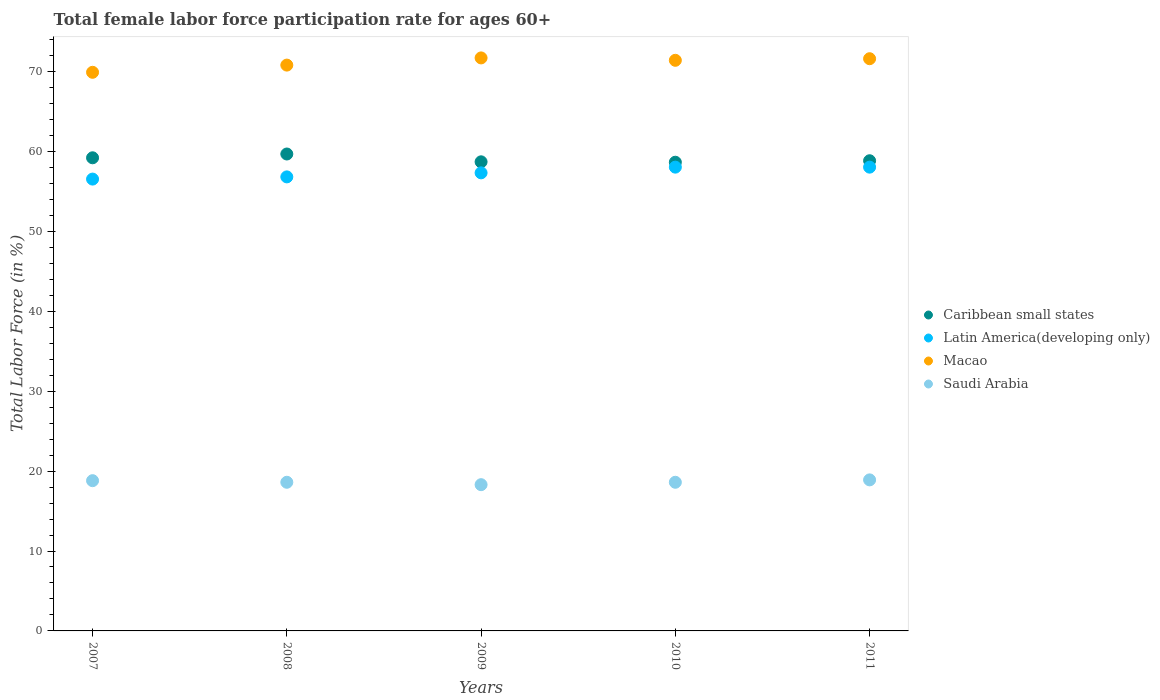How many different coloured dotlines are there?
Ensure brevity in your answer.  4. What is the female labor force participation rate in Saudi Arabia in 2007?
Provide a short and direct response. 18.8. Across all years, what is the maximum female labor force participation rate in Saudi Arabia?
Offer a terse response. 18.9. Across all years, what is the minimum female labor force participation rate in Saudi Arabia?
Your answer should be very brief. 18.3. In which year was the female labor force participation rate in Latin America(developing only) maximum?
Ensure brevity in your answer.  2010. In which year was the female labor force participation rate in Macao minimum?
Make the answer very short. 2007. What is the total female labor force participation rate in Latin America(developing only) in the graph?
Keep it short and to the point. 286.73. What is the difference between the female labor force participation rate in Saudi Arabia in 2008 and that in 2009?
Provide a short and direct response. 0.3. What is the difference between the female labor force participation rate in Saudi Arabia in 2011 and the female labor force participation rate in Macao in 2008?
Provide a succinct answer. -51.9. What is the average female labor force participation rate in Saudi Arabia per year?
Your answer should be very brief. 18.64. In the year 2008, what is the difference between the female labor force participation rate in Caribbean small states and female labor force participation rate in Saudi Arabia?
Your response must be concise. 41.08. In how many years, is the female labor force participation rate in Latin America(developing only) greater than 50 %?
Make the answer very short. 5. What is the ratio of the female labor force participation rate in Caribbean small states in 2009 to that in 2010?
Provide a short and direct response. 1. What is the difference between the highest and the second highest female labor force participation rate in Saudi Arabia?
Make the answer very short. 0.1. What is the difference between the highest and the lowest female labor force participation rate in Caribbean small states?
Keep it short and to the point. 1.03. In how many years, is the female labor force participation rate in Caribbean small states greater than the average female labor force participation rate in Caribbean small states taken over all years?
Offer a terse response. 2. Is the sum of the female labor force participation rate in Macao in 2008 and 2010 greater than the maximum female labor force participation rate in Latin America(developing only) across all years?
Your answer should be compact. Yes. Is it the case that in every year, the sum of the female labor force participation rate in Macao and female labor force participation rate in Latin America(developing only)  is greater than the sum of female labor force participation rate in Caribbean small states and female labor force participation rate in Saudi Arabia?
Provide a short and direct response. Yes. Does the female labor force participation rate in Latin America(developing only) monotonically increase over the years?
Provide a short and direct response. No. Is the female labor force participation rate in Caribbean small states strictly greater than the female labor force participation rate in Saudi Arabia over the years?
Ensure brevity in your answer.  Yes. How many years are there in the graph?
Your response must be concise. 5. Does the graph contain any zero values?
Offer a very short reply. No. Where does the legend appear in the graph?
Offer a terse response. Center right. How many legend labels are there?
Your response must be concise. 4. What is the title of the graph?
Your response must be concise. Total female labor force participation rate for ages 60+. Does "Lesotho" appear as one of the legend labels in the graph?
Your answer should be very brief. No. What is the label or title of the Y-axis?
Offer a very short reply. Total Labor Force (in %). What is the Total Labor Force (in %) in Caribbean small states in 2007?
Provide a short and direct response. 59.2. What is the Total Labor Force (in %) of Latin America(developing only) in 2007?
Make the answer very short. 56.54. What is the Total Labor Force (in %) in Macao in 2007?
Offer a very short reply. 69.9. What is the Total Labor Force (in %) in Saudi Arabia in 2007?
Keep it short and to the point. 18.8. What is the Total Labor Force (in %) in Caribbean small states in 2008?
Keep it short and to the point. 59.68. What is the Total Labor Force (in %) in Latin America(developing only) in 2008?
Offer a terse response. 56.81. What is the Total Labor Force (in %) of Macao in 2008?
Offer a very short reply. 70.8. What is the Total Labor Force (in %) of Saudi Arabia in 2008?
Provide a succinct answer. 18.6. What is the Total Labor Force (in %) in Caribbean small states in 2009?
Your answer should be compact. 58.7. What is the Total Labor Force (in %) in Latin America(developing only) in 2009?
Ensure brevity in your answer.  57.32. What is the Total Labor Force (in %) of Macao in 2009?
Give a very brief answer. 71.7. What is the Total Labor Force (in %) in Saudi Arabia in 2009?
Your response must be concise. 18.3. What is the Total Labor Force (in %) of Caribbean small states in 2010?
Provide a succinct answer. 58.65. What is the Total Labor Force (in %) in Latin America(developing only) in 2010?
Keep it short and to the point. 58.03. What is the Total Labor Force (in %) in Macao in 2010?
Give a very brief answer. 71.4. What is the Total Labor Force (in %) of Saudi Arabia in 2010?
Your response must be concise. 18.6. What is the Total Labor Force (in %) of Caribbean small states in 2011?
Your answer should be compact. 58.83. What is the Total Labor Force (in %) of Latin America(developing only) in 2011?
Make the answer very short. 58.03. What is the Total Labor Force (in %) of Macao in 2011?
Your answer should be compact. 71.6. What is the Total Labor Force (in %) of Saudi Arabia in 2011?
Offer a very short reply. 18.9. Across all years, what is the maximum Total Labor Force (in %) in Caribbean small states?
Offer a terse response. 59.68. Across all years, what is the maximum Total Labor Force (in %) of Latin America(developing only)?
Give a very brief answer. 58.03. Across all years, what is the maximum Total Labor Force (in %) of Macao?
Offer a very short reply. 71.7. Across all years, what is the maximum Total Labor Force (in %) in Saudi Arabia?
Provide a short and direct response. 18.9. Across all years, what is the minimum Total Labor Force (in %) of Caribbean small states?
Offer a very short reply. 58.65. Across all years, what is the minimum Total Labor Force (in %) in Latin America(developing only)?
Ensure brevity in your answer.  56.54. Across all years, what is the minimum Total Labor Force (in %) of Macao?
Ensure brevity in your answer.  69.9. Across all years, what is the minimum Total Labor Force (in %) in Saudi Arabia?
Your answer should be compact. 18.3. What is the total Total Labor Force (in %) in Caribbean small states in the graph?
Make the answer very short. 295.06. What is the total Total Labor Force (in %) in Latin America(developing only) in the graph?
Offer a very short reply. 286.73. What is the total Total Labor Force (in %) of Macao in the graph?
Your response must be concise. 355.4. What is the total Total Labor Force (in %) in Saudi Arabia in the graph?
Give a very brief answer. 93.2. What is the difference between the Total Labor Force (in %) of Caribbean small states in 2007 and that in 2008?
Your response must be concise. -0.47. What is the difference between the Total Labor Force (in %) of Latin America(developing only) in 2007 and that in 2008?
Provide a short and direct response. -0.28. What is the difference between the Total Labor Force (in %) in Caribbean small states in 2007 and that in 2009?
Offer a very short reply. 0.5. What is the difference between the Total Labor Force (in %) of Latin America(developing only) in 2007 and that in 2009?
Make the answer very short. -0.78. What is the difference between the Total Labor Force (in %) in Caribbean small states in 2007 and that in 2010?
Offer a terse response. 0.55. What is the difference between the Total Labor Force (in %) of Latin America(developing only) in 2007 and that in 2010?
Offer a terse response. -1.49. What is the difference between the Total Labor Force (in %) in Saudi Arabia in 2007 and that in 2010?
Your answer should be compact. 0.2. What is the difference between the Total Labor Force (in %) of Caribbean small states in 2007 and that in 2011?
Make the answer very short. 0.37. What is the difference between the Total Labor Force (in %) in Latin America(developing only) in 2007 and that in 2011?
Make the answer very short. -1.49. What is the difference between the Total Labor Force (in %) of Caribbean small states in 2008 and that in 2009?
Keep it short and to the point. 0.98. What is the difference between the Total Labor Force (in %) of Latin America(developing only) in 2008 and that in 2009?
Make the answer very short. -0.51. What is the difference between the Total Labor Force (in %) of Caribbean small states in 2008 and that in 2010?
Ensure brevity in your answer.  1.03. What is the difference between the Total Labor Force (in %) of Latin America(developing only) in 2008 and that in 2010?
Your answer should be compact. -1.22. What is the difference between the Total Labor Force (in %) in Macao in 2008 and that in 2010?
Provide a succinct answer. -0.6. What is the difference between the Total Labor Force (in %) of Saudi Arabia in 2008 and that in 2010?
Offer a very short reply. 0. What is the difference between the Total Labor Force (in %) in Caribbean small states in 2008 and that in 2011?
Your answer should be compact. 0.84. What is the difference between the Total Labor Force (in %) in Latin America(developing only) in 2008 and that in 2011?
Your response must be concise. -1.22. What is the difference between the Total Labor Force (in %) of Macao in 2008 and that in 2011?
Make the answer very short. -0.8. What is the difference between the Total Labor Force (in %) of Saudi Arabia in 2008 and that in 2011?
Provide a succinct answer. -0.3. What is the difference between the Total Labor Force (in %) of Caribbean small states in 2009 and that in 2010?
Provide a succinct answer. 0.05. What is the difference between the Total Labor Force (in %) of Latin America(developing only) in 2009 and that in 2010?
Give a very brief answer. -0.71. What is the difference between the Total Labor Force (in %) of Macao in 2009 and that in 2010?
Your answer should be very brief. 0.3. What is the difference between the Total Labor Force (in %) of Saudi Arabia in 2009 and that in 2010?
Offer a terse response. -0.3. What is the difference between the Total Labor Force (in %) of Caribbean small states in 2009 and that in 2011?
Your response must be concise. -0.13. What is the difference between the Total Labor Force (in %) in Latin America(developing only) in 2009 and that in 2011?
Keep it short and to the point. -0.71. What is the difference between the Total Labor Force (in %) of Caribbean small states in 2010 and that in 2011?
Make the answer very short. -0.19. What is the difference between the Total Labor Force (in %) in Latin America(developing only) in 2010 and that in 2011?
Your answer should be compact. 0. What is the difference between the Total Labor Force (in %) of Macao in 2010 and that in 2011?
Provide a short and direct response. -0.2. What is the difference between the Total Labor Force (in %) of Saudi Arabia in 2010 and that in 2011?
Your response must be concise. -0.3. What is the difference between the Total Labor Force (in %) of Caribbean small states in 2007 and the Total Labor Force (in %) of Latin America(developing only) in 2008?
Provide a short and direct response. 2.39. What is the difference between the Total Labor Force (in %) of Caribbean small states in 2007 and the Total Labor Force (in %) of Macao in 2008?
Keep it short and to the point. -11.6. What is the difference between the Total Labor Force (in %) of Caribbean small states in 2007 and the Total Labor Force (in %) of Saudi Arabia in 2008?
Provide a short and direct response. 40.6. What is the difference between the Total Labor Force (in %) of Latin America(developing only) in 2007 and the Total Labor Force (in %) of Macao in 2008?
Your response must be concise. -14.26. What is the difference between the Total Labor Force (in %) of Latin America(developing only) in 2007 and the Total Labor Force (in %) of Saudi Arabia in 2008?
Provide a short and direct response. 37.94. What is the difference between the Total Labor Force (in %) of Macao in 2007 and the Total Labor Force (in %) of Saudi Arabia in 2008?
Give a very brief answer. 51.3. What is the difference between the Total Labor Force (in %) in Caribbean small states in 2007 and the Total Labor Force (in %) in Latin America(developing only) in 2009?
Make the answer very short. 1.88. What is the difference between the Total Labor Force (in %) in Caribbean small states in 2007 and the Total Labor Force (in %) in Macao in 2009?
Your answer should be very brief. -12.5. What is the difference between the Total Labor Force (in %) in Caribbean small states in 2007 and the Total Labor Force (in %) in Saudi Arabia in 2009?
Offer a very short reply. 40.9. What is the difference between the Total Labor Force (in %) of Latin America(developing only) in 2007 and the Total Labor Force (in %) of Macao in 2009?
Give a very brief answer. -15.16. What is the difference between the Total Labor Force (in %) of Latin America(developing only) in 2007 and the Total Labor Force (in %) of Saudi Arabia in 2009?
Your answer should be very brief. 38.24. What is the difference between the Total Labor Force (in %) of Macao in 2007 and the Total Labor Force (in %) of Saudi Arabia in 2009?
Offer a very short reply. 51.6. What is the difference between the Total Labor Force (in %) in Caribbean small states in 2007 and the Total Labor Force (in %) in Latin America(developing only) in 2010?
Your answer should be very brief. 1.17. What is the difference between the Total Labor Force (in %) of Caribbean small states in 2007 and the Total Labor Force (in %) of Macao in 2010?
Make the answer very short. -12.2. What is the difference between the Total Labor Force (in %) in Caribbean small states in 2007 and the Total Labor Force (in %) in Saudi Arabia in 2010?
Your response must be concise. 40.6. What is the difference between the Total Labor Force (in %) of Latin America(developing only) in 2007 and the Total Labor Force (in %) of Macao in 2010?
Offer a terse response. -14.86. What is the difference between the Total Labor Force (in %) in Latin America(developing only) in 2007 and the Total Labor Force (in %) in Saudi Arabia in 2010?
Offer a terse response. 37.94. What is the difference between the Total Labor Force (in %) of Macao in 2007 and the Total Labor Force (in %) of Saudi Arabia in 2010?
Offer a terse response. 51.3. What is the difference between the Total Labor Force (in %) in Caribbean small states in 2007 and the Total Labor Force (in %) in Latin America(developing only) in 2011?
Provide a short and direct response. 1.17. What is the difference between the Total Labor Force (in %) in Caribbean small states in 2007 and the Total Labor Force (in %) in Macao in 2011?
Offer a very short reply. -12.4. What is the difference between the Total Labor Force (in %) of Caribbean small states in 2007 and the Total Labor Force (in %) of Saudi Arabia in 2011?
Your answer should be compact. 40.3. What is the difference between the Total Labor Force (in %) in Latin America(developing only) in 2007 and the Total Labor Force (in %) in Macao in 2011?
Your response must be concise. -15.06. What is the difference between the Total Labor Force (in %) of Latin America(developing only) in 2007 and the Total Labor Force (in %) of Saudi Arabia in 2011?
Ensure brevity in your answer.  37.64. What is the difference between the Total Labor Force (in %) in Macao in 2007 and the Total Labor Force (in %) in Saudi Arabia in 2011?
Keep it short and to the point. 51. What is the difference between the Total Labor Force (in %) in Caribbean small states in 2008 and the Total Labor Force (in %) in Latin America(developing only) in 2009?
Your answer should be very brief. 2.36. What is the difference between the Total Labor Force (in %) in Caribbean small states in 2008 and the Total Labor Force (in %) in Macao in 2009?
Your answer should be compact. -12.02. What is the difference between the Total Labor Force (in %) in Caribbean small states in 2008 and the Total Labor Force (in %) in Saudi Arabia in 2009?
Keep it short and to the point. 41.38. What is the difference between the Total Labor Force (in %) in Latin America(developing only) in 2008 and the Total Labor Force (in %) in Macao in 2009?
Your answer should be compact. -14.89. What is the difference between the Total Labor Force (in %) in Latin America(developing only) in 2008 and the Total Labor Force (in %) in Saudi Arabia in 2009?
Your answer should be very brief. 38.51. What is the difference between the Total Labor Force (in %) in Macao in 2008 and the Total Labor Force (in %) in Saudi Arabia in 2009?
Keep it short and to the point. 52.5. What is the difference between the Total Labor Force (in %) of Caribbean small states in 2008 and the Total Labor Force (in %) of Latin America(developing only) in 2010?
Make the answer very short. 1.64. What is the difference between the Total Labor Force (in %) of Caribbean small states in 2008 and the Total Labor Force (in %) of Macao in 2010?
Your response must be concise. -11.72. What is the difference between the Total Labor Force (in %) of Caribbean small states in 2008 and the Total Labor Force (in %) of Saudi Arabia in 2010?
Provide a short and direct response. 41.08. What is the difference between the Total Labor Force (in %) of Latin America(developing only) in 2008 and the Total Labor Force (in %) of Macao in 2010?
Provide a short and direct response. -14.59. What is the difference between the Total Labor Force (in %) of Latin America(developing only) in 2008 and the Total Labor Force (in %) of Saudi Arabia in 2010?
Your answer should be very brief. 38.21. What is the difference between the Total Labor Force (in %) of Macao in 2008 and the Total Labor Force (in %) of Saudi Arabia in 2010?
Ensure brevity in your answer.  52.2. What is the difference between the Total Labor Force (in %) of Caribbean small states in 2008 and the Total Labor Force (in %) of Latin America(developing only) in 2011?
Make the answer very short. 1.65. What is the difference between the Total Labor Force (in %) of Caribbean small states in 2008 and the Total Labor Force (in %) of Macao in 2011?
Your answer should be very brief. -11.92. What is the difference between the Total Labor Force (in %) in Caribbean small states in 2008 and the Total Labor Force (in %) in Saudi Arabia in 2011?
Your answer should be very brief. 40.78. What is the difference between the Total Labor Force (in %) of Latin America(developing only) in 2008 and the Total Labor Force (in %) of Macao in 2011?
Your response must be concise. -14.79. What is the difference between the Total Labor Force (in %) in Latin America(developing only) in 2008 and the Total Labor Force (in %) in Saudi Arabia in 2011?
Provide a short and direct response. 37.91. What is the difference between the Total Labor Force (in %) of Macao in 2008 and the Total Labor Force (in %) of Saudi Arabia in 2011?
Your answer should be very brief. 51.9. What is the difference between the Total Labor Force (in %) of Caribbean small states in 2009 and the Total Labor Force (in %) of Latin America(developing only) in 2010?
Keep it short and to the point. 0.67. What is the difference between the Total Labor Force (in %) of Caribbean small states in 2009 and the Total Labor Force (in %) of Macao in 2010?
Your answer should be very brief. -12.7. What is the difference between the Total Labor Force (in %) of Caribbean small states in 2009 and the Total Labor Force (in %) of Saudi Arabia in 2010?
Ensure brevity in your answer.  40.1. What is the difference between the Total Labor Force (in %) of Latin America(developing only) in 2009 and the Total Labor Force (in %) of Macao in 2010?
Provide a short and direct response. -14.08. What is the difference between the Total Labor Force (in %) of Latin America(developing only) in 2009 and the Total Labor Force (in %) of Saudi Arabia in 2010?
Make the answer very short. 38.72. What is the difference between the Total Labor Force (in %) of Macao in 2009 and the Total Labor Force (in %) of Saudi Arabia in 2010?
Give a very brief answer. 53.1. What is the difference between the Total Labor Force (in %) of Caribbean small states in 2009 and the Total Labor Force (in %) of Latin America(developing only) in 2011?
Ensure brevity in your answer.  0.67. What is the difference between the Total Labor Force (in %) in Caribbean small states in 2009 and the Total Labor Force (in %) in Macao in 2011?
Your answer should be very brief. -12.9. What is the difference between the Total Labor Force (in %) in Caribbean small states in 2009 and the Total Labor Force (in %) in Saudi Arabia in 2011?
Make the answer very short. 39.8. What is the difference between the Total Labor Force (in %) of Latin America(developing only) in 2009 and the Total Labor Force (in %) of Macao in 2011?
Keep it short and to the point. -14.28. What is the difference between the Total Labor Force (in %) of Latin America(developing only) in 2009 and the Total Labor Force (in %) of Saudi Arabia in 2011?
Make the answer very short. 38.42. What is the difference between the Total Labor Force (in %) of Macao in 2009 and the Total Labor Force (in %) of Saudi Arabia in 2011?
Your answer should be very brief. 52.8. What is the difference between the Total Labor Force (in %) in Caribbean small states in 2010 and the Total Labor Force (in %) in Latin America(developing only) in 2011?
Your answer should be compact. 0.62. What is the difference between the Total Labor Force (in %) of Caribbean small states in 2010 and the Total Labor Force (in %) of Macao in 2011?
Make the answer very short. -12.95. What is the difference between the Total Labor Force (in %) of Caribbean small states in 2010 and the Total Labor Force (in %) of Saudi Arabia in 2011?
Give a very brief answer. 39.75. What is the difference between the Total Labor Force (in %) of Latin America(developing only) in 2010 and the Total Labor Force (in %) of Macao in 2011?
Make the answer very short. -13.57. What is the difference between the Total Labor Force (in %) in Latin America(developing only) in 2010 and the Total Labor Force (in %) in Saudi Arabia in 2011?
Make the answer very short. 39.13. What is the difference between the Total Labor Force (in %) of Macao in 2010 and the Total Labor Force (in %) of Saudi Arabia in 2011?
Offer a terse response. 52.5. What is the average Total Labor Force (in %) in Caribbean small states per year?
Ensure brevity in your answer.  59.01. What is the average Total Labor Force (in %) in Latin America(developing only) per year?
Provide a succinct answer. 57.35. What is the average Total Labor Force (in %) of Macao per year?
Keep it short and to the point. 71.08. What is the average Total Labor Force (in %) in Saudi Arabia per year?
Make the answer very short. 18.64. In the year 2007, what is the difference between the Total Labor Force (in %) of Caribbean small states and Total Labor Force (in %) of Latin America(developing only)?
Make the answer very short. 2.66. In the year 2007, what is the difference between the Total Labor Force (in %) of Caribbean small states and Total Labor Force (in %) of Macao?
Your answer should be compact. -10.7. In the year 2007, what is the difference between the Total Labor Force (in %) of Caribbean small states and Total Labor Force (in %) of Saudi Arabia?
Offer a very short reply. 40.4. In the year 2007, what is the difference between the Total Labor Force (in %) in Latin America(developing only) and Total Labor Force (in %) in Macao?
Keep it short and to the point. -13.36. In the year 2007, what is the difference between the Total Labor Force (in %) of Latin America(developing only) and Total Labor Force (in %) of Saudi Arabia?
Your answer should be compact. 37.74. In the year 2007, what is the difference between the Total Labor Force (in %) of Macao and Total Labor Force (in %) of Saudi Arabia?
Your answer should be compact. 51.1. In the year 2008, what is the difference between the Total Labor Force (in %) of Caribbean small states and Total Labor Force (in %) of Latin America(developing only)?
Offer a very short reply. 2.86. In the year 2008, what is the difference between the Total Labor Force (in %) of Caribbean small states and Total Labor Force (in %) of Macao?
Provide a short and direct response. -11.12. In the year 2008, what is the difference between the Total Labor Force (in %) of Caribbean small states and Total Labor Force (in %) of Saudi Arabia?
Make the answer very short. 41.08. In the year 2008, what is the difference between the Total Labor Force (in %) in Latin America(developing only) and Total Labor Force (in %) in Macao?
Your answer should be compact. -13.99. In the year 2008, what is the difference between the Total Labor Force (in %) of Latin America(developing only) and Total Labor Force (in %) of Saudi Arabia?
Offer a very short reply. 38.21. In the year 2008, what is the difference between the Total Labor Force (in %) of Macao and Total Labor Force (in %) of Saudi Arabia?
Give a very brief answer. 52.2. In the year 2009, what is the difference between the Total Labor Force (in %) of Caribbean small states and Total Labor Force (in %) of Latin America(developing only)?
Offer a very short reply. 1.38. In the year 2009, what is the difference between the Total Labor Force (in %) of Caribbean small states and Total Labor Force (in %) of Macao?
Keep it short and to the point. -13. In the year 2009, what is the difference between the Total Labor Force (in %) of Caribbean small states and Total Labor Force (in %) of Saudi Arabia?
Your answer should be very brief. 40.4. In the year 2009, what is the difference between the Total Labor Force (in %) in Latin America(developing only) and Total Labor Force (in %) in Macao?
Give a very brief answer. -14.38. In the year 2009, what is the difference between the Total Labor Force (in %) in Latin America(developing only) and Total Labor Force (in %) in Saudi Arabia?
Give a very brief answer. 39.02. In the year 2009, what is the difference between the Total Labor Force (in %) of Macao and Total Labor Force (in %) of Saudi Arabia?
Ensure brevity in your answer.  53.4. In the year 2010, what is the difference between the Total Labor Force (in %) in Caribbean small states and Total Labor Force (in %) in Latin America(developing only)?
Ensure brevity in your answer.  0.62. In the year 2010, what is the difference between the Total Labor Force (in %) of Caribbean small states and Total Labor Force (in %) of Macao?
Give a very brief answer. -12.75. In the year 2010, what is the difference between the Total Labor Force (in %) in Caribbean small states and Total Labor Force (in %) in Saudi Arabia?
Your answer should be very brief. 40.05. In the year 2010, what is the difference between the Total Labor Force (in %) in Latin America(developing only) and Total Labor Force (in %) in Macao?
Make the answer very short. -13.37. In the year 2010, what is the difference between the Total Labor Force (in %) in Latin America(developing only) and Total Labor Force (in %) in Saudi Arabia?
Ensure brevity in your answer.  39.43. In the year 2010, what is the difference between the Total Labor Force (in %) of Macao and Total Labor Force (in %) of Saudi Arabia?
Your answer should be very brief. 52.8. In the year 2011, what is the difference between the Total Labor Force (in %) of Caribbean small states and Total Labor Force (in %) of Latin America(developing only)?
Give a very brief answer. 0.8. In the year 2011, what is the difference between the Total Labor Force (in %) in Caribbean small states and Total Labor Force (in %) in Macao?
Offer a very short reply. -12.77. In the year 2011, what is the difference between the Total Labor Force (in %) in Caribbean small states and Total Labor Force (in %) in Saudi Arabia?
Offer a terse response. 39.93. In the year 2011, what is the difference between the Total Labor Force (in %) in Latin America(developing only) and Total Labor Force (in %) in Macao?
Your answer should be compact. -13.57. In the year 2011, what is the difference between the Total Labor Force (in %) in Latin America(developing only) and Total Labor Force (in %) in Saudi Arabia?
Your answer should be compact. 39.13. In the year 2011, what is the difference between the Total Labor Force (in %) of Macao and Total Labor Force (in %) of Saudi Arabia?
Keep it short and to the point. 52.7. What is the ratio of the Total Labor Force (in %) of Latin America(developing only) in 2007 to that in 2008?
Provide a succinct answer. 1. What is the ratio of the Total Labor Force (in %) in Macao in 2007 to that in 2008?
Keep it short and to the point. 0.99. What is the ratio of the Total Labor Force (in %) of Saudi Arabia in 2007 to that in 2008?
Provide a short and direct response. 1.01. What is the ratio of the Total Labor Force (in %) of Caribbean small states in 2007 to that in 2009?
Provide a succinct answer. 1.01. What is the ratio of the Total Labor Force (in %) of Latin America(developing only) in 2007 to that in 2009?
Keep it short and to the point. 0.99. What is the ratio of the Total Labor Force (in %) of Macao in 2007 to that in 2009?
Provide a succinct answer. 0.97. What is the ratio of the Total Labor Force (in %) of Saudi Arabia in 2007 to that in 2009?
Your answer should be very brief. 1.03. What is the ratio of the Total Labor Force (in %) in Caribbean small states in 2007 to that in 2010?
Ensure brevity in your answer.  1.01. What is the ratio of the Total Labor Force (in %) in Latin America(developing only) in 2007 to that in 2010?
Make the answer very short. 0.97. What is the ratio of the Total Labor Force (in %) of Saudi Arabia in 2007 to that in 2010?
Make the answer very short. 1.01. What is the ratio of the Total Labor Force (in %) of Caribbean small states in 2007 to that in 2011?
Ensure brevity in your answer.  1.01. What is the ratio of the Total Labor Force (in %) in Latin America(developing only) in 2007 to that in 2011?
Give a very brief answer. 0.97. What is the ratio of the Total Labor Force (in %) in Macao in 2007 to that in 2011?
Your answer should be compact. 0.98. What is the ratio of the Total Labor Force (in %) of Caribbean small states in 2008 to that in 2009?
Give a very brief answer. 1.02. What is the ratio of the Total Labor Force (in %) of Macao in 2008 to that in 2009?
Provide a short and direct response. 0.99. What is the ratio of the Total Labor Force (in %) of Saudi Arabia in 2008 to that in 2009?
Your response must be concise. 1.02. What is the ratio of the Total Labor Force (in %) in Caribbean small states in 2008 to that in 2010?
Ensure brevity in your answer.  1.02. What is the ratio of the Total Labor Force (in %) in Saudi Arabia in 2008 to that in 2010?
Your answer should be very brief. 1. What is the ratio of the Total Labor Force (in %) of Caribbean small states in 2008 to that in 2011?
Your answer should be very brief. 1.01. What is the ratio of the Total Labor Force (in %) of Latin America(developing only) in 2008 to that in 2011?
Provide a succinct answer. 0.98. What is the ratio of the Total Labor Force (in %) of Macao in 2008 to that in 2011?
Provide a short and direct response. 0.99. What is the ratio of the Total Labor Force (in %) of Saudi Arabia in 2008 to that in 2011?
Provide a short and direct response. 0.98. What is the ratio of the Total Labor Force (in %) in Caribbean small states in 2009 to that in 2010?
Provide a succinct answer. 1. What is the ratio of the Total Labor Force (in %) in Latin America(developing only) in 2009 to that in 2010?
Make the answer very short. 0.99. What is the ratio of the Total Labor Force (in %) in Macao in 2009 to that in 2010?
Offer a very short reply. 1. What is the ratio of the Total Labor Force (in %) in Saudi Arabia in 2009 to that in 2010?
Make the answer very short. 0.98. What is the ratio of the Total Labor Force (in %) in Latin America(developing only) in 2009 to that in 2011?
Your response must be concise. 0.99. What is the ratio of the Total Labor Force (in %) of Macao in 2009 to that in 2011?
Your response must be concise. 1. What is the ratio of the Total Labor Force (in %) in Saudi Arabia in 2009 to that in 2011?
Your answer should be very brief. 0.97. What is the ratio of the Total Labor Force (in %) in Caribbean small states in 2010 to that in 2011?
Provide a succinct answer. 1. What is the ratio of the Total Labor Force (in %) in Saudi Arabia in 2010 to that in 2011?
Provide a short and direct response. 0.98. What is the difference between the highest and the second highest Total Labor Force (in %) in Caribbean small states?
Provide a succinct answer. 0.47. What is the difference between the highest and the second highest Total Labor Force (in %) of Latin America(developing only)?
Your answer should be compact. 0. What is the difference between the highest and the second highest Total Labor Force (in %) in Macao?
Provide a succinct answer. 0.1. What is the difference between the highest and the lowest Total Labor Force (in %) of Caribbean small states?
Offer a very short reply. 1.03. What is the difference between the highest and the lowest Total Labor Force (in %) in Latin America(developing only)?
Give a very brief answer. 1.49. What is the difference between the highest and the lowest Total Labor Force (in %) of Macao?
Offer a very short reply. 1.8. What is the difference between the highest and the lowest Total Labor Force (in %) of Saudi Arabia?
Provide a succinct answer. 0.6. 